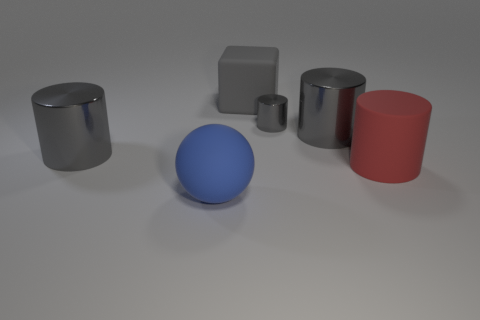What can you infer about the materials the objects are made from? The objects in the image appear to have a matte finish, which suggests they are likely made from a rubber-like material. This is evident from the soft reflections and lack of high gloss, which would otherwise imply a metallic or glass construction. 